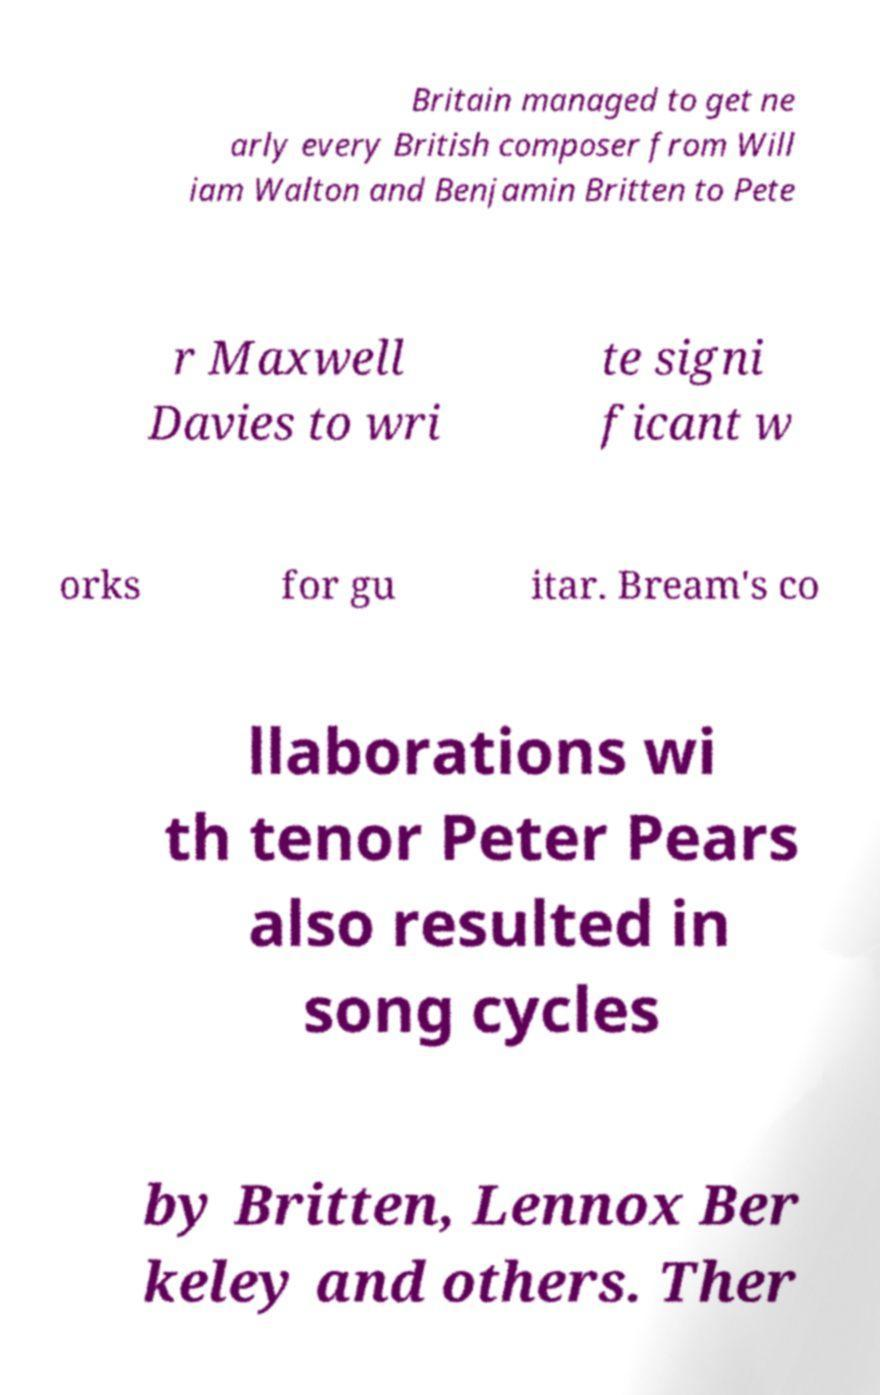For documentation purposes, I need the text within this image transcribed. Could you provide that? Britain managed to get ne arly every British composer from Will iam Walton and Benjamin Britten to Pete r Maxwell Davies to wri te signi ficant w orks for gu itar. Bream's co llaborations wi th tenor Peter Pears also resulted in song cycles by Britten, Lennox Ber keley and others. Ther 